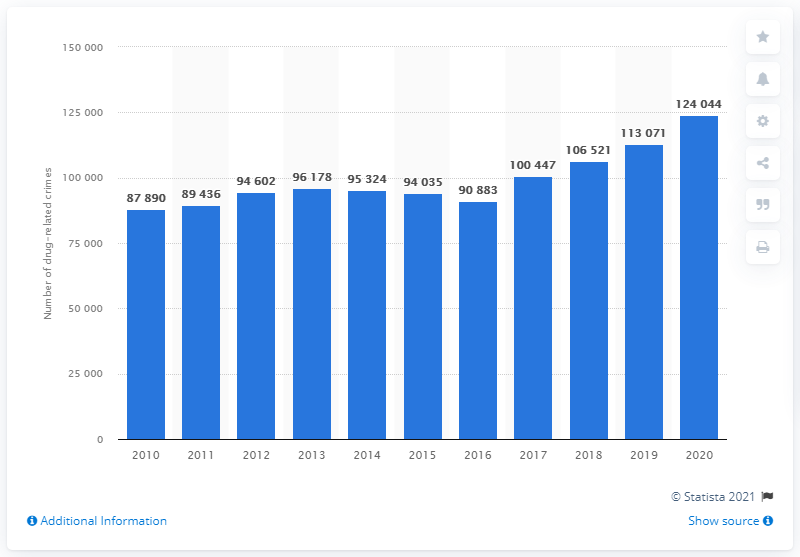Identify some key points in this picture. It is reported that in 2010, there were 8,789 drug-related crimes reported in Sweden. In 2020, a total of 124,044 drug-related crimes were reported in Sweden. 